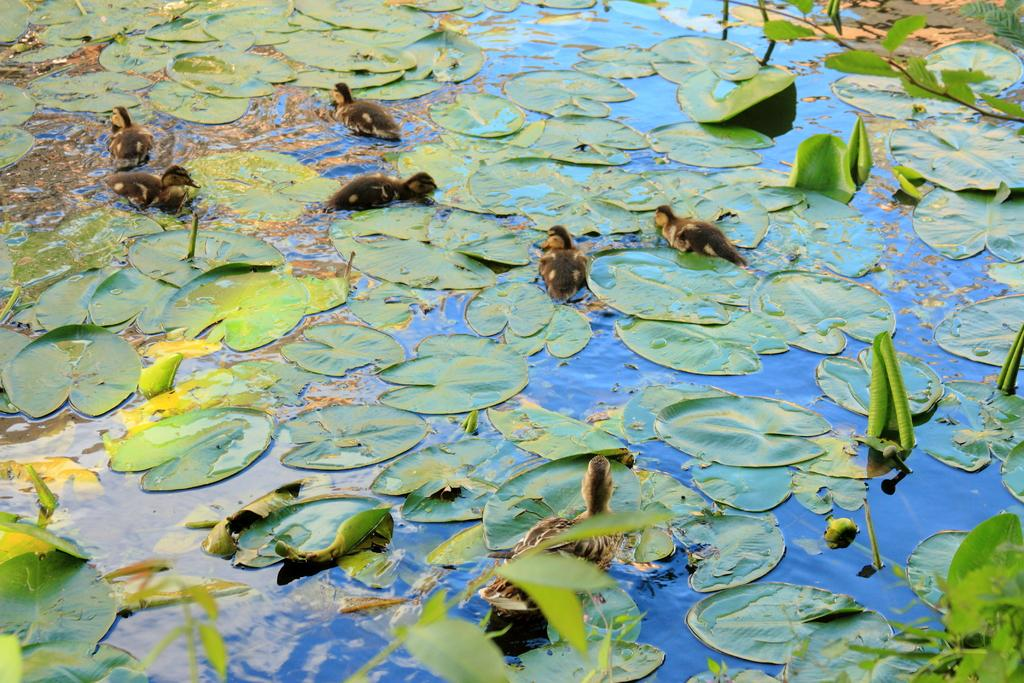What type of plant is visible in the image? There are lotus leaves in the image. What is the location of the birds in the image? The birds are on the water in the image. How many grapes are hanging from the lotus leaves in the image? There are no grapes present in the image; it features lotus leaves and birds on the water. What page is the bird sitting on in the image? There is no page present in the image; it is a natural scene with lotus leaves and birds on the water. 